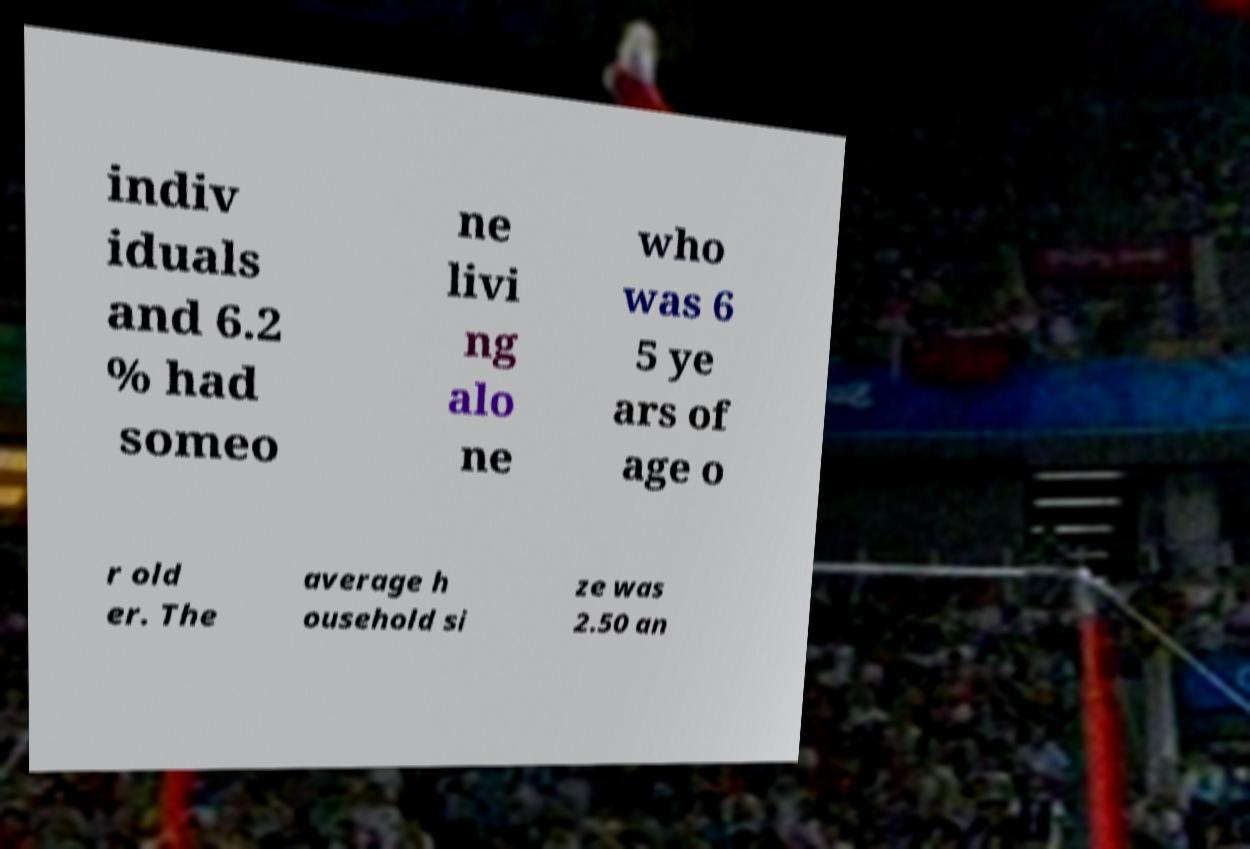Can you accurately transcribe the text from the provided image for me? indiv iduals and 6.2 % had someo ne livi ng alo ne who was 6 5 ye ars of age o r old er. The average h ousehold si ze was 2.50 an 